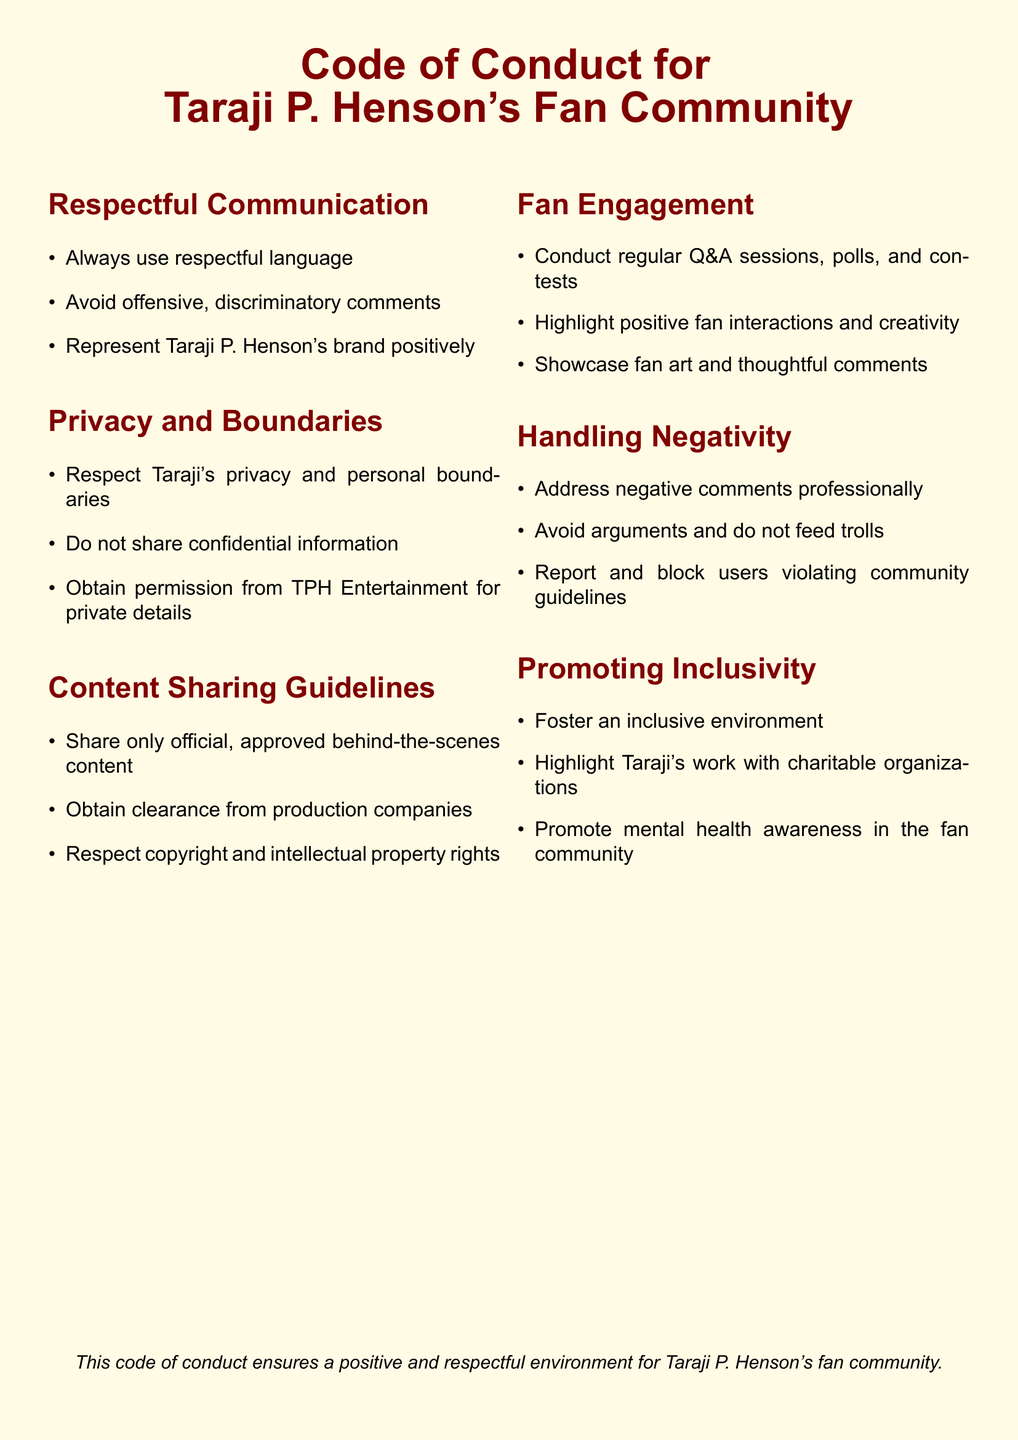What is the title of the document? The title of the document specifies what it covers, which is related to Taraji P. Henson's fan community.
Answer: Code of Conduct for Taraji P. Henson's Fan Community How many sections are there in the document? The document is divided into six specific sections that outline guidelines and principles.
Answer: Six What is emphasized in the "Respectful Communication" section? This section highlights the importance of language used while communicating with the community and respecting the brand.
Answer: Respectful language What should be obtained before sharing private details? The document specifies that permission must be sought before sharing certain private information regarding Taraji P. Henson.
Answer: Permission from TPH Entertainment What action should be taken toward users violating community guidelines? The document recommends an appropriate response to ensure community safety and adherence to guidelines.
Answer: Report and block What is encouraged in the "Fan Engagement" section? This section specifies activities that enhance interaction within the fan community, fostering a positive environment.
Answer: Regular Q&A sessions What type of environment does the document aim to promote? The document clearly aims to create a welcoming atmosphere for all fans of Taraji P. Henson.
Answer: Inclusive environment How should negative comments be handled? The document outlines a professional approach to dealing with negativity, advising members to maintain composure.
Answer: Address professionally 